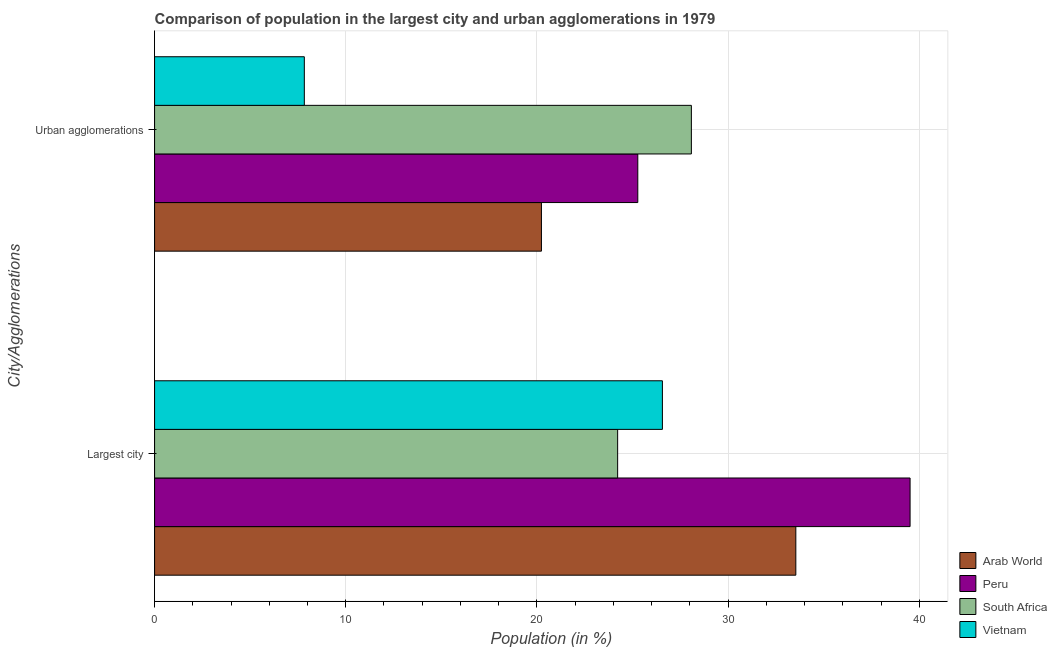How many different coloured bars are there?
Your response must be concise. 4. How many groups of bars are there?
Make the answer very short. 2. Are the number of bars on each tick of the Y-axis equal?
Provide a short and direct response. Yes. What is the label of the 1st group of bars from the top?
Your answer should be compact. Urban agglomerations. What is the population in the largest city in Vietnam?
Offer a very short reply. 26.56. Across all countries, what is the maximum population in the largest city?
Provide a short and direct response. 39.52. Across all countries, what is the minimum population in the largest city?
Your answer should be compact. 24.22. In which country was the population in urban agglomerations maximum?
Make the answer very short. South Africa. In which country was the population in the largest city minimum?
Your answer should be very brief. South Africa. What is the total population in the largest city in the graph?
Keep it short and to the point. 123.85. What is the difference between the population in the largest city in Vietnam and that in Peru?
Give a very brief answer. -12.96. What is the difference between the population in urban agglomerations in Peru and the population in the largest city in Vietnam?
Ensure brevity in your answer.  -1.29. What is the average population in urban agglomerations per country?
Your response must be concise. 20.36. What is the difference between the population in urban agglomerations and population in the largest city in Vietnam?
Your answer should be very brief. -18.73. In how many countries, is the population in the largest city greater than 18 %?
Offer a terse response. 4. What is the ratio of the population in the largest city in Arab World to that in Peru?
Give a very brief answer. 0.85. In how many countries, is the population in urban agglomerations greater than the average population in urban agglomerations taken over all countries?
Make the answer very short. 2. What does the 4th bar from the top in Largest city represents?
Offer a very short reply. Arab World. What does the 3rd bar from the bottom in Urban agglomerations represents?
Offer a very short reply. South Africa. How many bars are there?
Make the answer very short. 8. Are all the bars in the graph horizontal?
Your response must be concise. Yes. What is the difference between two consecutive major ticks on the X-axis?
Ensure brevity in your answer.  10. Does the graph contain grids?
Offer a very short reply. Yes. How many legend labels are there?
Your response must be concise. 4. How are the legend labels stacked?
Give a very brief answer. Vertical. What is the title of the graph?
Provide a succinct answer. Comparison of population in the largest city and urban agglomerations in 1979. Does "Thailand" appear as one of the legend labels in the graph?
Keep it short and to the point. No. What is the label or title of the Y-axis?
Provide a short and direct response. City/Agglomerations. What is the Population (in %) of Arab World in Largest city?
Your answer should be compact. 33.54. What is the Population (in %) in Peru in Largest city?
Provide a short and direct response. 39.52. What is the Population (in %) of South Africa in Largest city?
Provide a succinct answer. 24.22. What is the Population (in %) in Vietnam in Largest city?
Keep it short and to the point. 26.56. What is the Population (in %) in Arab World in Urban agglomerations?
Give a very brief answer. 20.24. What is the Population (in %) of Peru in Urban agglomerations?
Ensure brevity in your answer.  25.28. What is the Population (in %) in South Africa in Urban agglomerations?
Give a very brief answer. 28.08. What is the Population (in %) of Vietnam in Urban agglomerations?
Ensure brevity in your answer.  7.83. Across all City/Agglomerations, what is the maximum Population (in %) in Arab World?
Provide a succinct answer. 33.54. Across all City/Agglomerations, what is the maximum Population (in %) in Peru?
Give a very brief answer. 39.52. Across all City/Agglomerations, what is the maximum Population (in %) in South Africa?
Your answer should be compact. 28.08. Across all City/Agglomerations, what is the maximum Population (in %) in Vietnam?
Ensure brevity in your answer.  26.56. Across all City/Agglomerations, what is the minimum Population (in %) of Arab World?
Your answer should be compact. 20.24. Across all City/Agglomerations, what is the minimum Population (in %) of Peru?
Ensure brevity in your answer.  25.28. Across all City/Agglomerations, what is the minimum Population (in %) of South Africa?
Give a very brief answer. 24.22. Across all City/Agglomerations, what is the minimum Population (in %) in Vietnam?
Make the answer very short. 7.83. What is the total Population (in %) of Arab World in the graph?
Ensure brevity in your answer.  53.78. What is the total Population (in %) of Peru in the graph?
Give a very brief answer. 64.8. What is the total Population (in %) of South Africa in the graph?
Give a very brief answer. 52.3. What is the total Population (in %) in Vietnam in the graph?
Provide a short and direct response. 34.4. What is the difference between the Population (in %) in Arab World in Largest city and that in Urban agglomerations?
Your answer should be compact. 13.31. What is the difference between the Population (in %) in Peru in Largest city and that in Urban agglomerations?
Make the answer very short. 14.24. What is the difference between the Population (in %) of South Africa in Largest city and that in Urban agglomerations?
Provide a short and direct response. -3.86. What is the difference between the Population (in %) in Vietnam in Largest city and that in Urban agglomerations?
Keep it short and to the point. 18.73. What is the difference between the Population (in %) of Arab World in Largest city and the Population (in %) of Peru in Urban agglomerations?
Provide a short and direct response. 8.27. What is the difference between the Population (in %) in Arab World in Largest city and the Population (in %) in South Africa in Urban agglomerations?
Provide a short and direct response. 5.46. What is the difference between the Population (in %) in Arab World in Largest city and the Population (in %) in Vietnam in Urban agglomerations?
Provide a succinct answer. 25.71. What is the difference between the Population (in %) of Peru in Largest city and the Population (in %) of South Africa in Urban agglomerations?
Offer a terse response. 11.44. What is the difference between the Population (in %) of Peru in Largest city and the Population (in %) of Vietnam in Urban agglomerations?
Offer a terse response. 31.69. What is the difference between the Population (in %) of South Africa in Largest city and the Population (in %) of Vietnam in Urban agglomerations?
Keep it short and to the point. 16.39. What is the average Population (in %) of Arab World per City/Agglomerations?
Your answer should be compact. 26.89. What is the average Population (in %) of Peru per City/Agglomerations?
Make the answer very short. 32.4. What is the average Population (in %) of South Africa per City/Agglomerations?
Keep it short and to the point. 26.15. What is the average Population (in %) of Vietnam per City/Agglomerations?
Provide a short and direct response. 17.2. What is the difference between the Population (in %) in Arab World and Population (in %) in Peru in Largest city?
Your answer should be compact. -5.98. What is the difference between the Population (in %) in Arab World and Population (in %) in South Africa in Largest city?
Offer a terse response. 9.32. What is the difference between the Population (in %) of Arab World and Population (in %) of Vietnam in Largest city?
Ensure brevity in your answer.  6.98. What is the difference between the Population (in %) of Peru and Population (in %) of South Africa in Largest city?
Your answer should be compact. 15.3. What is the difference between the Population (in %) of Peru and Population (in %) of Vietnam in Largest city?
Offer a terse response. 12.96. What is the difference between the Population (in %) in South Africa and Population (in %) in Vietnam in Largest city?
Your response must be concise. -2.34. What is the difference between the Population (in %) of Arab World and Population (in %) of Peru in Urban agglomerations?
Make the answer very short. -5.04. What is the difference between the Population (in %) in Arab World and Population (in %) in South Africa in Urban agglomerations?
Keep it short and to the point. -7.84. What is the difference between the Population (in %) of Arab World and Population (in %) of Vietnam in Urban agglomerations?
Provide a succinct answer. 12.4. What is the difference between the Population (in %) of Peru and Population (in %) of South Africa in Urban agglomerations?
Provide a succinct answer. -2.8. What is the difference between the Population (in %) of Peru and Population (in %) of Vietnam in Urban agglomerations?
Make the answer very short. 17.44. What is the difference between the Population (in %) of South Africa and Population (in %) of Vietnam in Urban agglomerations?
Make the answer very short. 20.25. What is the ratio of the Population (in %) of Arab World in Largest city to that in Urban agglomerations?
Give a very brief answer. 1.66. What is the ratio of the Population (in %) in Peru in Largest city to that in Urban agglomerations?
Offer a terse response. 1.56. What is the ratio of the Population (in %) in South Africa in Largest city to that in Urban agglomerations?
Provide a succinct answer. 0.86. What is the ratio of the Population (in %) in Vietnam in Largest city to that in Urban agglomerations?
Provide a short and direct response. 3.39. What is the difference between the highest and the second highest Population (in %) in Arab World?
Provide a short and direct response. 13.31. What is the difference between the highest and the second highest Population (in %) of Peru?
Keep it short and to the point. 14.24. What is the difference between the highest and the second highest Population (in %) of South Africa?
Make the answer very short. 3.86. What is the difference between the highest and the second highest Population (in %) in Vietnam?
Offer a very short reply. 18.73. What is the difference between the highest and the lowest Population (in %) of Arab World?
Give a very brief answer. 13.31. What is the difference between the highest and the lowest Population (in %) in Peru?
Provide a succinct answer. 14.24. What is the difference between the highest and the lowest Population (in %) in South Africa?
Keep it short and to the point. 3.86. What is the difference between the highest and the lowest Population (in %) of Vietnam?
Offer a very short reply. 18.73. 